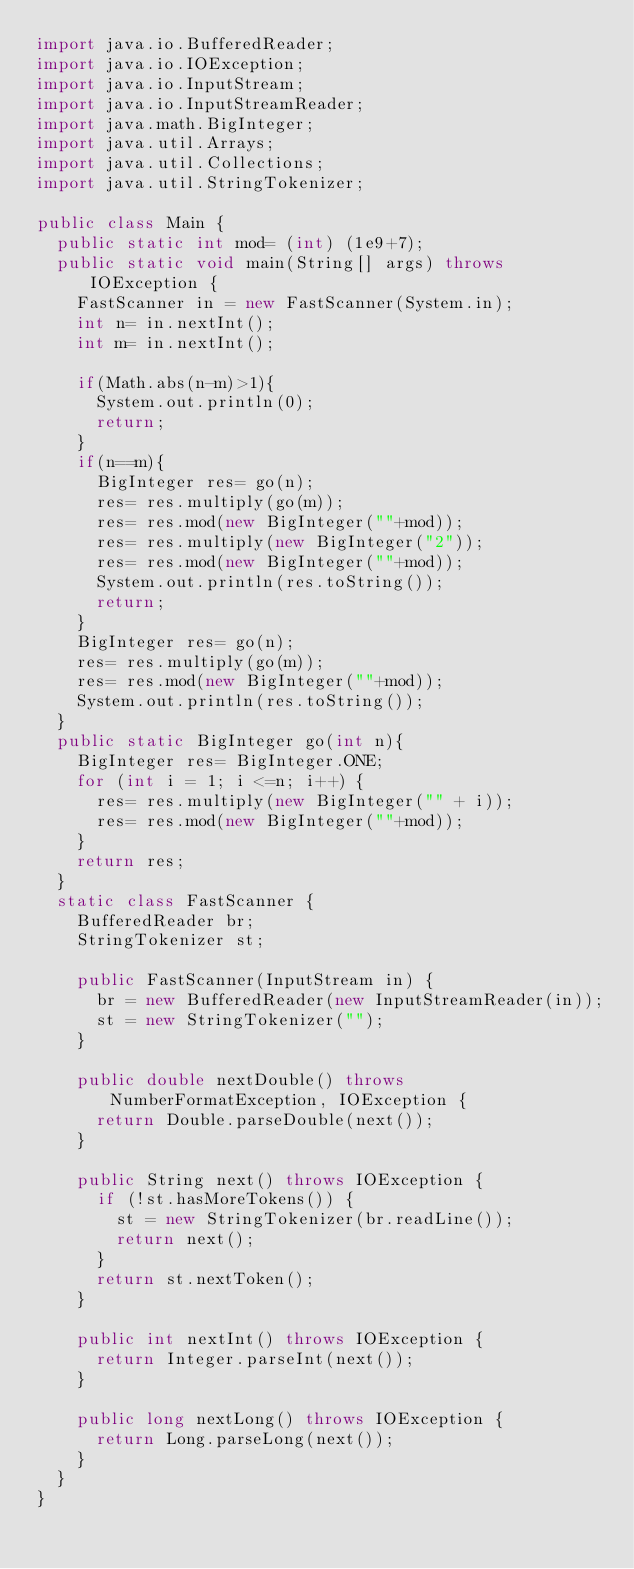Convert code to text. <code><loc_0><loc_0><loc_500><loc_500><_Java_>import java.io.BufferedReader;
import java.io.IOException;
import java.io.InputStream;
import java.io.InputStreamReader;
import java.math.BigInteger;
import java.util.Arrays;
import java.util.Collections;
import java.util.StringTokenizer;

public class Main {
	public static int mod= (int) (1e9+7);
	public static void main(String[] args) throws IOException {
		FastScanner in = new FastScanner(System.in);
		int n= in.nextInt();
		int m= in.nextInt();
		
		if(Math.abs(n-m)>1){
			System.out.println(0);
			return;
		}
		if(n==m){
			BigInteger res= go(n);
			res= res.multiply(go(m));
			res= res.mod(new BigInteger(""+mod));
			res= res.multiply(new BigInteger("2"));
			res= res.mod(new BigInteger(""+mod));
			System.out.println(res.toString());
			return;
		}
		BigInteger res= go(n);
		res= res.multiply(go(m));
		res= res.mod(new BigInteger(""+mod));
		System.out.println(res.toString());
	}
	public static BigInteger go(int n){
		BigInteger res= BigInteger.ONE;
		for (int i = 1; i <=n; i++) {
			res= res.multiply(new BigInteger("" + i));
			res= res.mod(new BigInteger(""+mod));
		}
		return res;
	}
	static class FastScanner {
		BufferedReader br;
		StringTokenizer st;

		public FastScanner(InputStream in) {
			br = new BufferedReader(new InputStreamReader(in));
			st = new StringTokenizer("");
		}

		public double nextDouble() throws NumberFormatException, IOException {
			return Double.parseDouble(next());
		}

		public String next() throws IOException {
			if (!st.hasMoreTokens()) {
				st = new StringTokenizer(br.readLine());
				return next();
			}
			return st.nextToken();
		}

		public int nextInt() throws IOException {
			return Integer.parseInt(next());
		}

		public long nextLong() throws IOException {
			return Long.parseLong(next());
		}
	}
}
</code> 